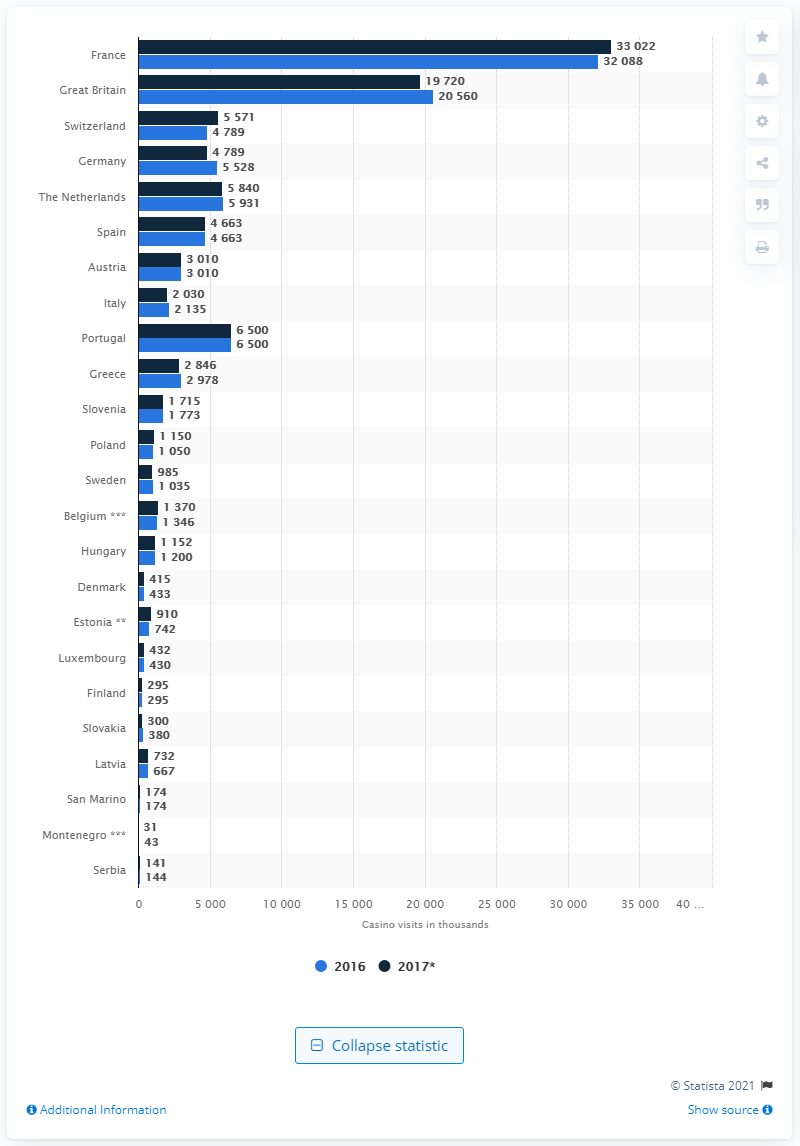Highlight a few significant elements in this photo. In 2017, there were 33,022 casino player visits in France. 